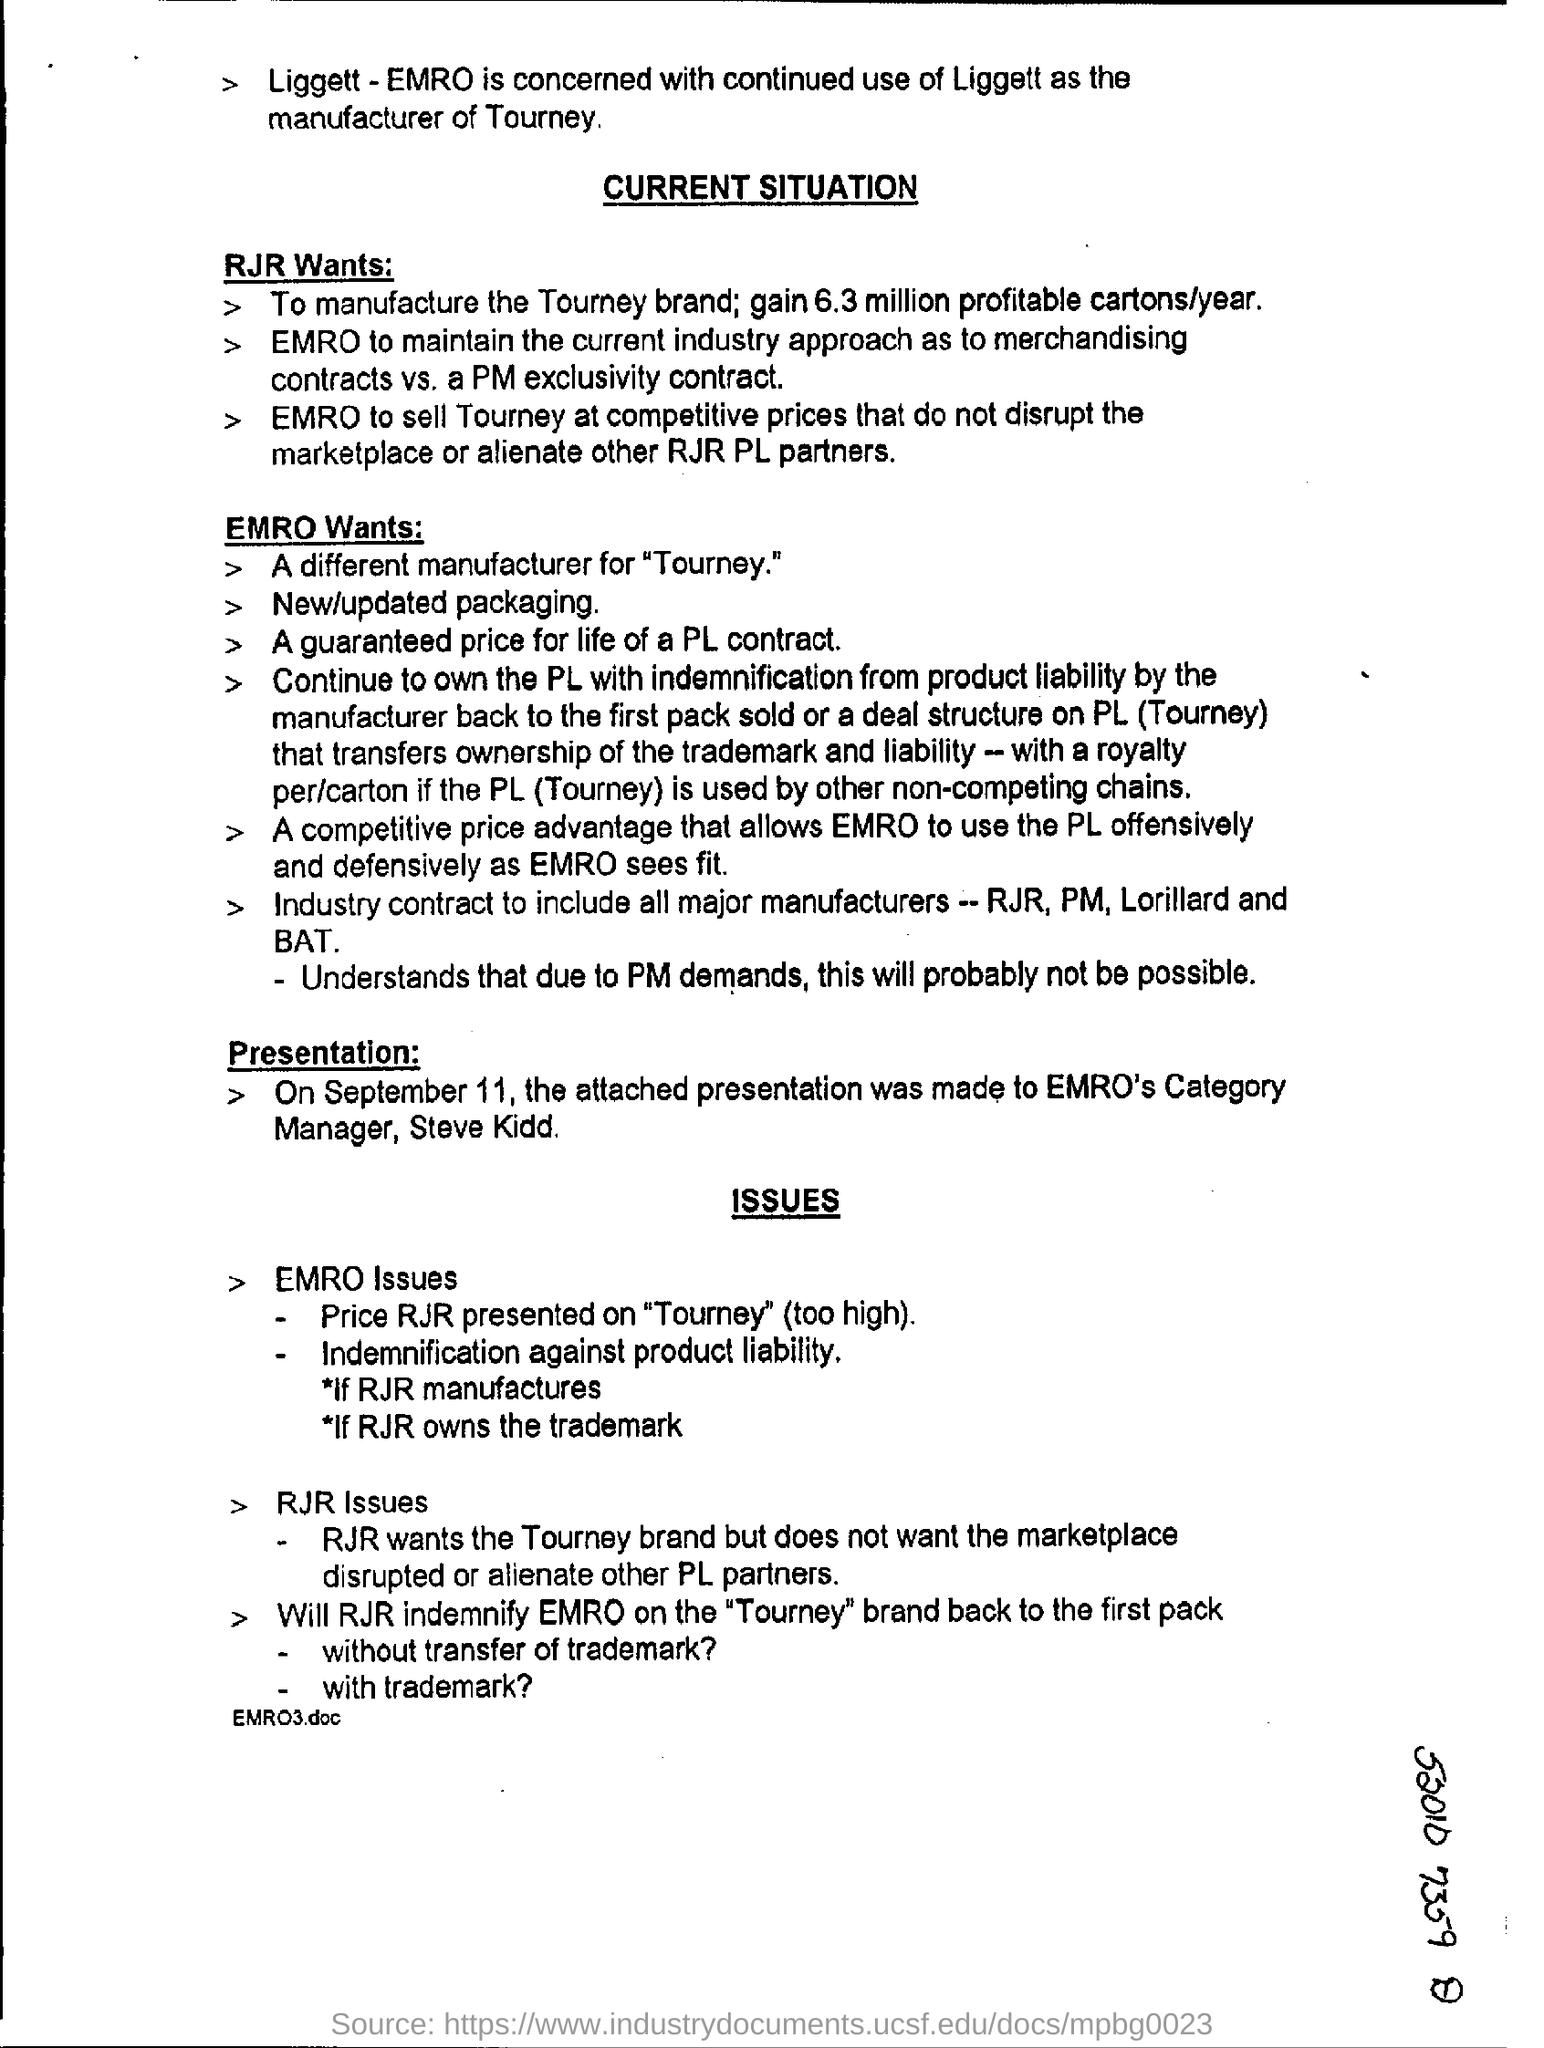Find out the quantity of Cartons RJR wants to manufacture?
Your answer should be compact. 6.3 million. What is the presentation date?
Your answer should be very brief. SEPTEMBER 11. 